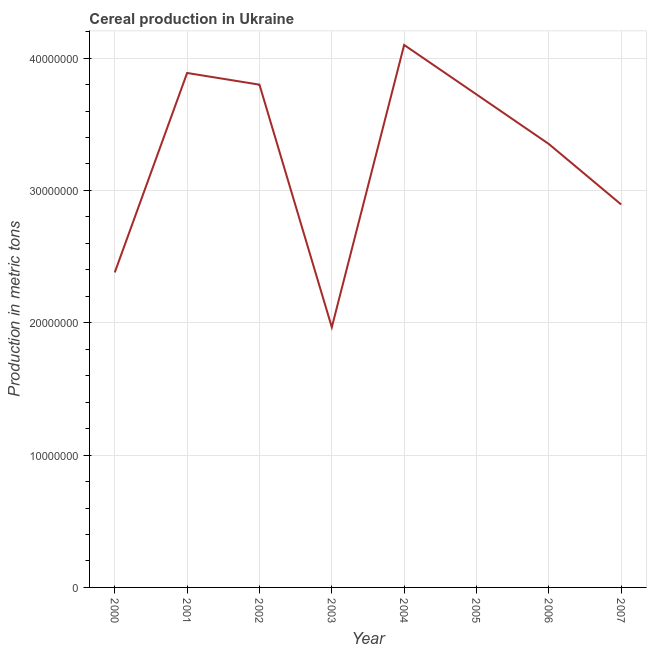What is the cereal production in 2001?
Ensure brevity in your answer.  3.89e+07. Across all years, what is the maximum cereal production?
Give a very brief answer. 4.10e+07. Across all years, what is the minimum cereal production?
Ensure brevity in your answer.  1.97e+07. In which year was the cereal production minimum?
Provide a short and direct response. 2003. What is the sum of the cereal production?
Your response must be concise. 2.61e+08. What is the difference between the cereal production in 2001 and 2003?
Your response must be concise. 1.92e+07. What is the average cereal production per year?
Provide a short and direct response. 3.26e+07. What is the median cereal production?
Make the answer very short. 3.54e+07. In how many years, is the cereal production greater than 30000000 metric tons?
Give a very brief answer. 5. Do a majority of the years between 2002 and 2005 (inclusive) have cereal production greater than 20000000 metric tons?
Make the answer very short. Yes. What is the ratio of the cereal production in 2003 to that in 2005?
Your answer should be compact. 0.53. Is the cereal production in 2005 less than that in 2006?
Your answer should be compact. No. Is the difference between the cereal production in 2003 and 2004 greater than the difference between any two years?
Your response must be concise. Yes. What is the difference between the highest and the second highest cereal production?
Make the answer very short. 2.12e+06. Is the sum of the cereal production in 2000 and 2001 greater than the maximum cereal production across all years?
Ensure brevity in your answer.  Yes. What is the difference between the highest and the lowest cereal production?
Make the answer very short. 2.13e+07. Does the cereal production monotonically increase over the years?
Make the answer very short. No. Are the values on the major ticks of Y-axis written in scientific E-notation?
Ensure brevity in your answer.  No. What is the title of the graph?
Ensure brevity in your answer.  Cereal production in Ukraine. What is the label or title of the X-axis?
Your answer should be compact. Year. What is the label or title of the Y-axis?
Ensure brevity in your answer.  Production in metric tons. What is the Production in metric tons in 2000?
Make the answer very short. 2.38e+07. What is the Production in metric tons in 2001?
Give a very brief answer. 3.89e+07. What is the Production in metric tons in 2002?
Keep it short and to the point. 3.80e+07. What is the Production in metric tons in 2003?
Your response must be concise. 1.97e+07. What is the Production in metric tons of 2004?
Offer a very short reply. 4.10e+07. What is the Production in metric tons of 2005?
Your answer should be compact. 3.73e+07. What is the Production in metric tons of 2006?
Your answer should be compact. 3.35e+07. What is the Production in metric tons of 2007?
Ensure brevity in your answer.  2.89e+07. What is the difference between the Production in metric tons in 2000 and 2001?
Your answer should be compact. -1.51e+07. What is the difference between the Production in metric tons in 2000 and 2002?
Keep it short and to the point. -1.42e+07. What is the difference between the Production in metric tons in 2000 and 2003?
Your answer should be very brief. 4.14e+06. What is the difference between the Production in metric tons in 2000 and 2004?
Ensure brevity in your answer.  -1.72e+07. What is the difference between the Production in metric tons in 2000 and 2005?
Ensure brevity in your answer.  -1.35e+07. What is the difference between the Production in metric tons in 2000 and 2006?
Keep it short and to the point. -9.70e+06. What is the difference between the Production in metric tons in 2000 and 2007?
Provide a succinct answer. -5.13e+06. What is the difference between the Production in metric tons in 2001 and 2002?
Ensure brevity in your answer.  8.84e+05. What is the difference between the Production in metric tons in 2001 and 2003?
Your answer should be compact. 1.92e+07. What is the difference between the Production in metric tons in 2001 and 2004?
Provide a short and direct response. -2.12e+06. What is the difference between the Production in metric tons in 2001 and 2005?
Your answer should be very brief. 1.62e+06. What is the difference between the Production in metric tons in 2001 and 2006?
Provide a short and direct response. 5.37e+06. What is the difference between the Production in metric tons in 2001 and 2007?
Your answer should be compact. 9.94e+06. What is the difference between the Production in metric tons in 2002 and 2003?
Make the answer very short. 1.83e+07. What is the difference between the Production in metric tons in 2002 and 2004?
Offer a very short reply. -3.00e+06. What is the difference between the Production in metric tons in 2002 and 2005?
Provide a short and direct response. 7.37e+05. What is the difference between the Production in metric tons in 2002 and 2006?
Your answer should be compact. 4.48e+06. What is the difference between the Production in metric tons in 2002 and 2007?
Ensure brevity in your answer.  9.06e+06. What is the difference between the Production in metric tons in 2003 and 2004?
Keep it short and to the point. -2.13e+07. What is the difference between the Production in metric tons in 2003 and 2005?
Ensure brevity in your answer.  -1.76e+07. What is the difference between the Production in metric tons in 2003 and 2006?
Your answer should be compact. -1.38e+07. What is the difference between the Production in metric tons in 2003 and 2007?
Provide a short and direct response. -9.28e+06. What is the difference between the Production in metric tons in 2004 and 2005?
Give a very brief answer. 3.74e+06. What is the difference between the Production in metric tons in 2004 and 2006?
Offer a terse response. 7.49e+06. What is the difference between the Production in metric tons in 2004 and 2007?
Your answer should be very brief. 1.21e+07. What is the difference between the Production in metric tons in 2005 and 2006?
Offer a very short reply. 3.75e+06. What is the difference between the Production in metric tons in 2005 and 2007?
Your answer should be compact. 8.32e+06. What is the difference between the Production in metric tons in 2006 and 2007?
Your answer should be compact. 4.57e+06. What is the ratio of the Production in metric tons in 2000 to that in 2001?
Your response must be concise. 0.61. What is the ratio of the Production in metric tons in 2000 to that in 2002?
Offer a very short reply. 0.63. What is the ratio of the Production in metric tons in 2000 to that in 2003?
Provide a succinct answer. 1.21. What is the ratio of the Production in metric tons in 2000 to that in 2004?
Keep it short and to the point. 0.58. What is the ratio of the Production in metric tons in 2000 to that in 2005?
Your response must be concise. 0.64. What is the ratio of the Production in metric tons in 2000 to that in 2006?
Your answer should be very brief. 0.71. What is the ratio of the Production in metric tons in 2000 to that in 2007?
Offer a very short reply. 0.82. What is the ratio of the Production in metric tons in 2001 to that in 2002?
Keep it short and to the point. 1.02. What is the ratio of the Production in metric tons in 2001 to that in 2003?
Offer a terse response. 1.98. What is the ratio of the Production in metric tons in 2001 to that in 2004?
Your answer should be compact. 0.95. What is the ratio of the Production in metric tons in 2001 to that in 2005?
Offer a terse response. 1.04. What is the ratio of the Production in metric tons in 2001 to that in 2006?
Provide a succinct answer. 1.16. What is the ratio of the Production in metric tons in 2001 to that in 2007?
Make the answer very short. 1.34. What is the ratio of the Production in metric tons in 2002 to that in 2003?
Ensure brevity in your answer.  1.93. What is the ratio of the Production in metric tons in 2002 to that in 2004?
Give a very brief answer. 0.93. What is the ratio of the Production in metric tons in 2002 to that in 2006?
Your answer should be compact. 1.13. What is the ratio of the Production in metric tons in 2002 to that in 2007?
Ensure brevity in your answer.  1.31. What is the ratio of the Production in metric tons in 2003 to that in 2004?
Your response must be concise. 0.48. What is the ratio of the Production in metric tons in 2003 to that in 2005?
Ensure brevity in your answer.  0.53. What is the ratio of the Production in metric tons in 2003 to that in 2006?
Ensure brevity in your answer.  0.59. What is the ratio of the Production in metric tons in 2003 to that in 2007?
Give a very brief answer. 0.68. What is the ratio of the Production in metric tons in 2004 to that in 2005?
Offer a terse response. 1.1. What is the ratio of the Production in metric tons in 2004 to that in 2006?
Offer a terse response. 1.22. What is the ratio of the Production in metric tons in 2004 to that in 2007?
Provide a succinct answer. 1.42. What is the ratio of the Production in metric tons in 2005 to that in 2006?
Provide a succinct answer. 1.11. What is the ratio of the Production in metric tons in 2005 to that in 2007?
Ensure brevity in your answer.  1.29. What is the ratio of the Production in metric tons in 2006 to that in 2007?
Offer a very short reply. 1.16. 